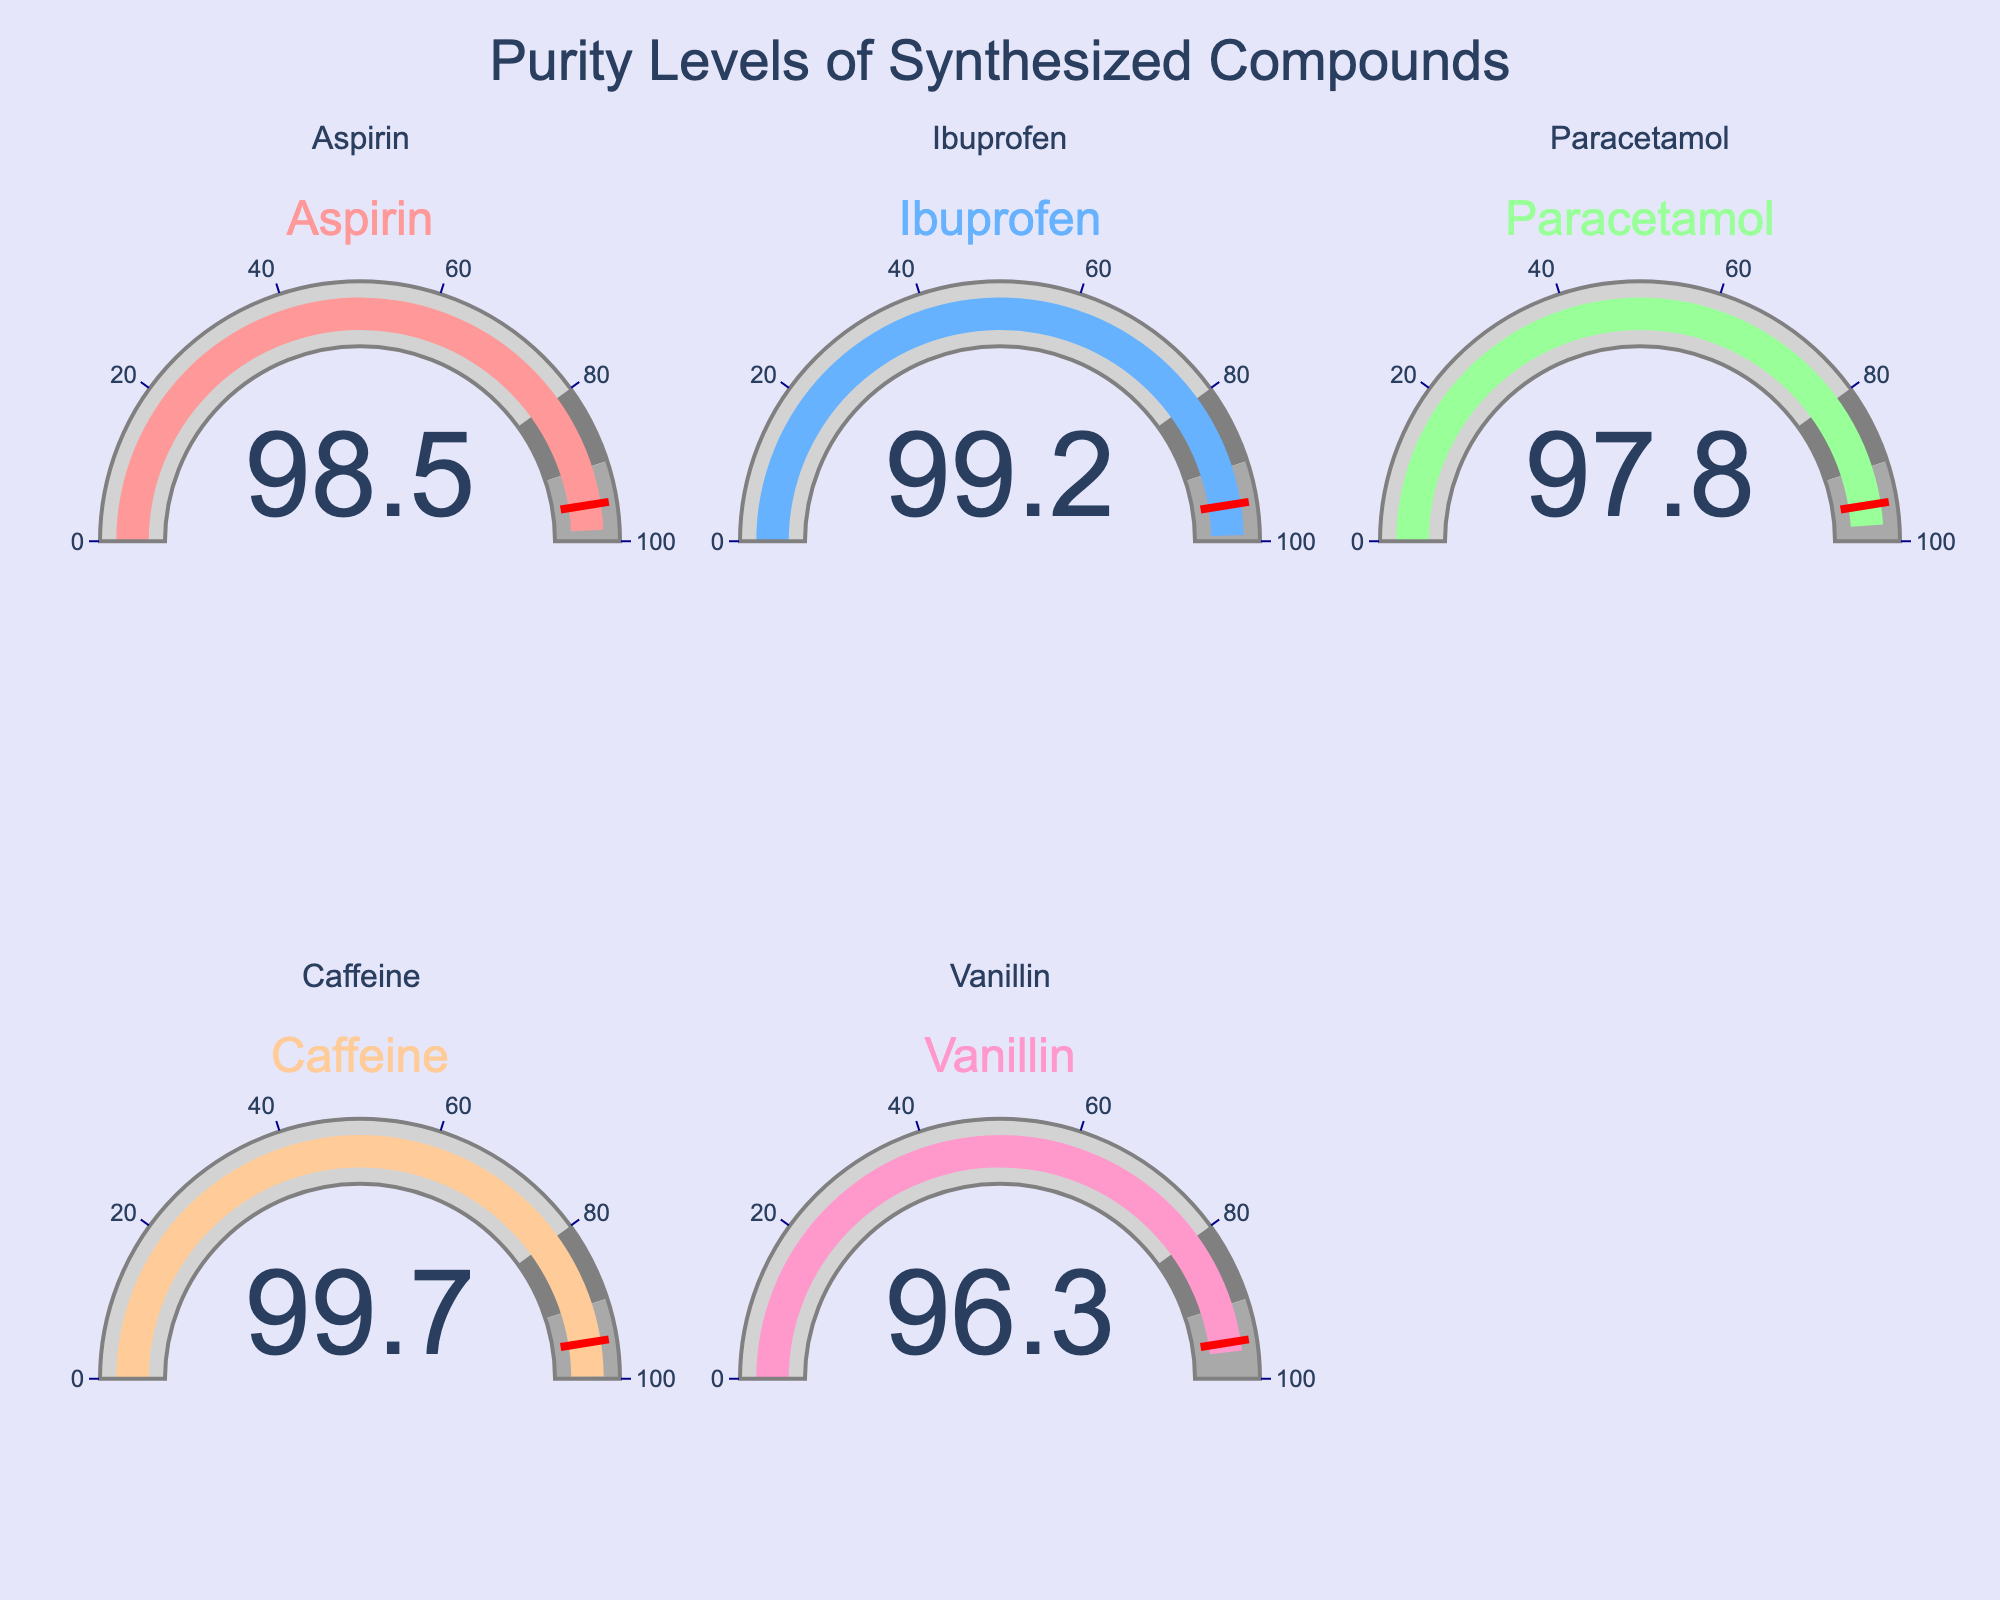What is the purity level of Vanillin? The gauge for Vanillin shows a value on the dial indicating the purity. The value displayed directly on the gauge is the purity level.
Answer: 96.3 Which compound has the highest purity level? There are five gauges representing different compounds. By comparing the values displayed on each gauge, Caffeine has the highest purity level as it shows the largest number.
Answer: Caffeine What is the title of the plot? The title is usually displayed at the top of the plot, centering and indicating the main subject of the chart.
Answer: Purity Levels of Synthesized Compounds Is the purity level of Paracetamol above the threshold of 95? The threshold is set by a red line on the gauge at the value of 95. The gauge for Paracetamol shows a value above this threshold.
Answer: Yes How many compounds have a purity above 98%? By looking at each gauge, identify the compounds with purity levels greater than 98. Aspirin, Ibuprofen, and Caffeine are above 98%.
Answer: 3 Which compound has a lower purity level: Aspirin or Ibuprofen? To answer this, compare the values on the gauges for both Aspirin and Ibuprofen. Aspirin shows a lower number compared to Ibuprofen.
Answer: Aspirin What is the average purity level of all the compounds? Sum all the purity levels and divide by the number of compounds. The sum is (98.5 + 99.2 + 97.8 + 99.7 + 96.3) = 491.5. Dividing by 5 gives 491.5 / 5 = 98.3
Answer: 98.3 What colors are used for the gauge bars, and which compound is associated with each color? Observe the colors of the gauge bars and match them with the corresponding compounds: Aspirin (#FF9999), Ibuprofen (#66B2FF), Paracetamol (#99FF99), Caffeine (#FFCC99), Vanillin (#FF99CC).
Answer: Aspirin (pink), Ibuprofen (light blue), Paracetamol (light green), Caffeine (peach), Vanillin (pinkish-pink) 